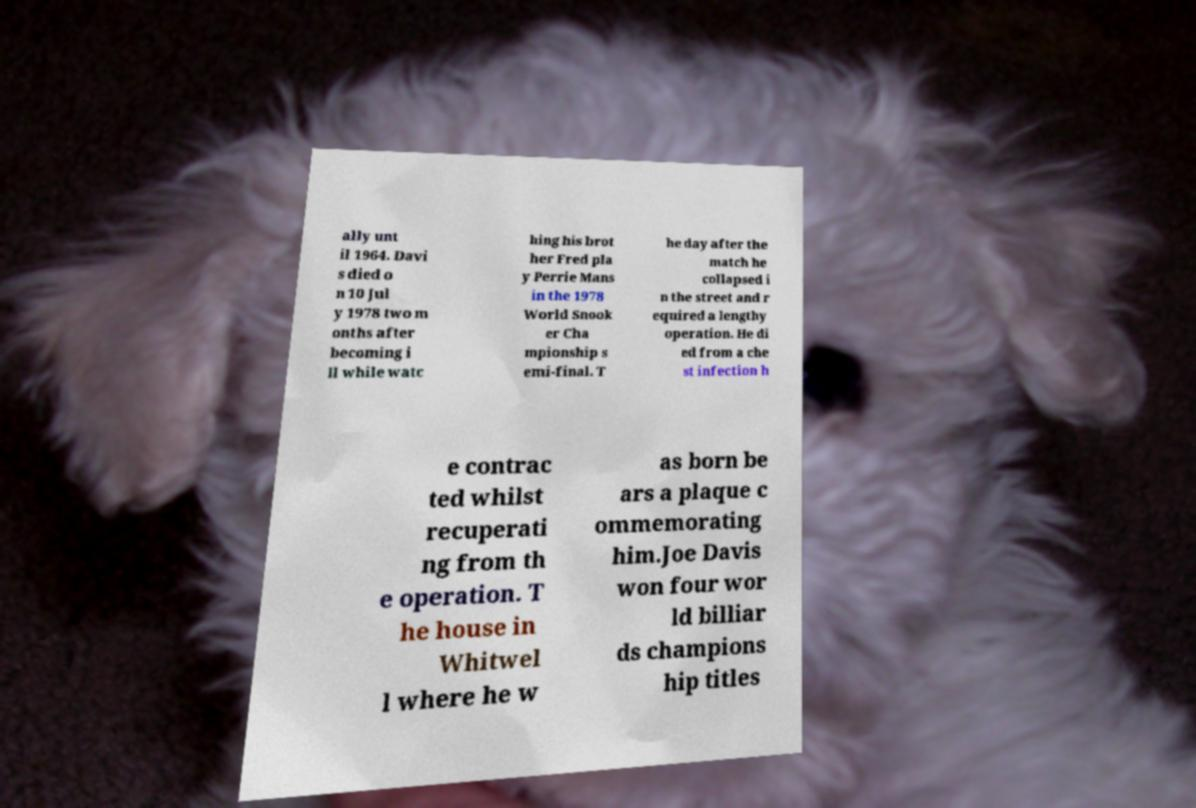I need the written content from this picture converted into text. Can you do that? ally unt il 1964. Davi s died o n 10 Jul y 1978 two m onths after becoming i ll while watc hing his brot her Fred pla y Perrie Mans in the 1978 World Snook er Cha mpionship s emi-final. T he day after the match he collapsed i n the street and r equired a lengthy operation. He di ed from a che st infection h e contrac ted whilst recuperati ng from th e operation. T he house in Whitwel l where he w as born be ars a plaque c ommemorating him.Joe Davis won four wor ld billiar ds champions hip titles 